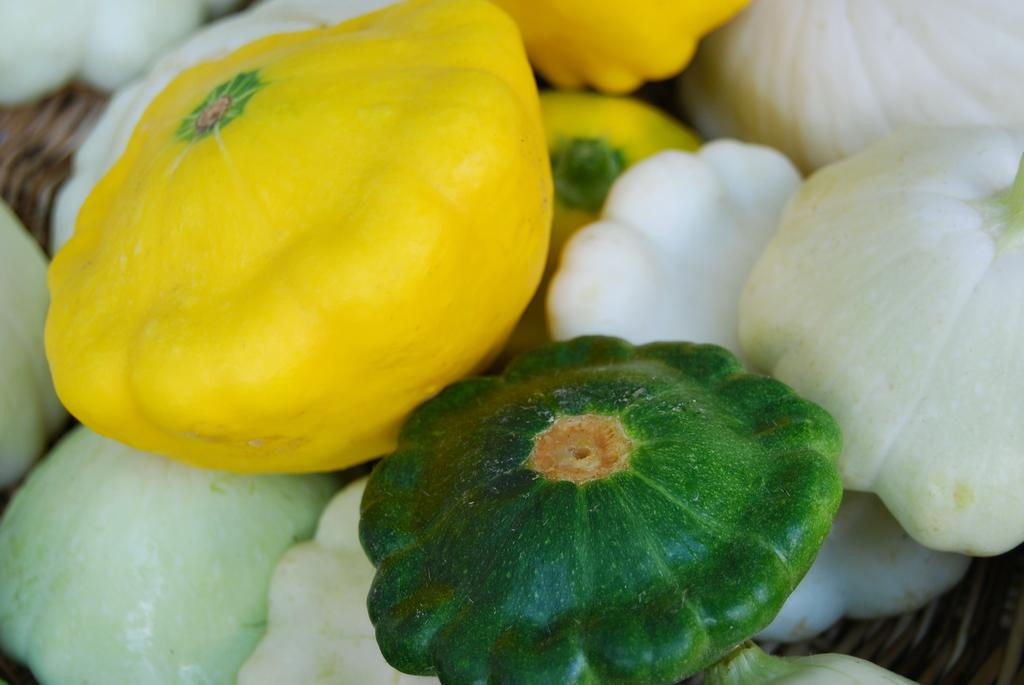What type of food is present in the image? There are vegetables in the image. Can you describe the colors of the vegetables? The vegetables have yellow, white, and green colors. What type of collar can be seen on the goldfish in the image? There is no goldfish or collar present in the image; it features vegetables with yellow, white, and green colors. 